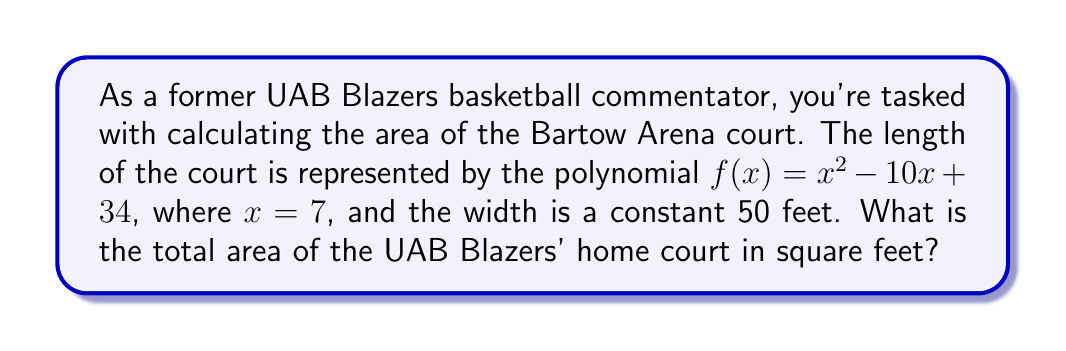Provide a solution to this math problem. Let's approach this step-by-step:

1) We're given that the length of the court is represented by $f(x) = x^2 - 10x + 34$, where $x = 7$.

2) To find the length, we need to calculate $f(7)$:

   $f(7) = 7^2 - 10(7) + 34$
   $= 49 - 70 + 34$
   $= 13$ feet

3) We're told the width is a constant 50 feet.

4) The area of a rectangle is given by the formula:

   $A = l \times w$

   Where $A$ is the area, $l$ is the length, and $w$ is the width.

5) Substituting our values:

   $A = 13 \times 50$
   $= 650$ square feet

Therefore, the total area of the UAB Blazers' home court is 650 square feet.
Answer: 650 sq ft 